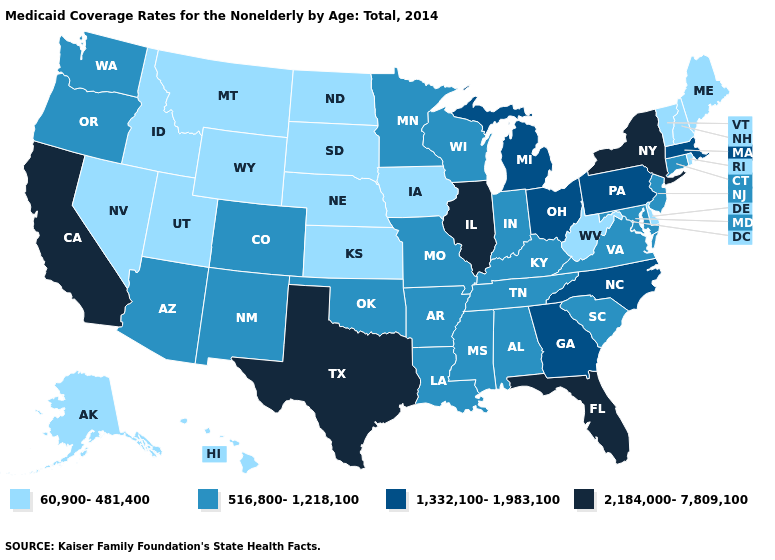What is the lowest value in the USA?
Keep it brief. 60,900-481,400. Does Kansas have a lower value than New Hampshire?
Quick response, please. No. What is the highest value in the West ?
Be succinct. 2,184,000-7,809,100. What is the highest value in states that border Illinois?
Concise answer only. 516,800-1,218,100. Name the states that have a value in the range 516,800-1,218,100?
Be succinct. Alabama, Arizona, Arkansas, Colorado, Connecticut, Indiana, Kentucky, Louisiana, Maryland, Minnesota, Mississippi, Missouri, New Jersey, New Mexico, Oklahoma, Oregon, South Carolina, Tennessee, Virginia, Washington, Wisconsin. What is the highest value in the South ?
Keep it brief. 2,184,000-7,809,100. Name the states that have a value in the range 2,184,000-7,809,100?
Answer briefly. California, Florida, Illinois, New York, Texas. What is the value of Georgia?
Give a very brief answer. 1,332,100-1,983,100. What is the lowest value in states that border California?
Keep it brief. 60,900-481,400. What is the value of Florida?
Concise answer only. 2,184,000-7,809,100. Among the states that border Kansas , which have the highest value?
Keep it brief. Colorado, Missouri, Oklahoma. What is the lowest value in the USA?
Short answer required. 60,900-481,400. Name the states that have a value in the range 1,332,100-1,983,100?
Quick response, please. Georgia, Massachusetts, Michigan, North Carolina, Ohio, Pennsylvania. Which states hav the highest value in the West?
Give a very brief answer. California. Name the states that have a value in the range 516,800-1,218,100?
Write a very short answer. Alabama, Arizona, Arkansas, Colorado, Connecticut, Indiana, Kentucky, Louisiana, Maryland, Minnesota, Mississippi, Missouri, New Jersey, New Mexico, Oklahoma, Oregon, South Carolina, Tennessee, Virginia, Washington, Wisconsin. 